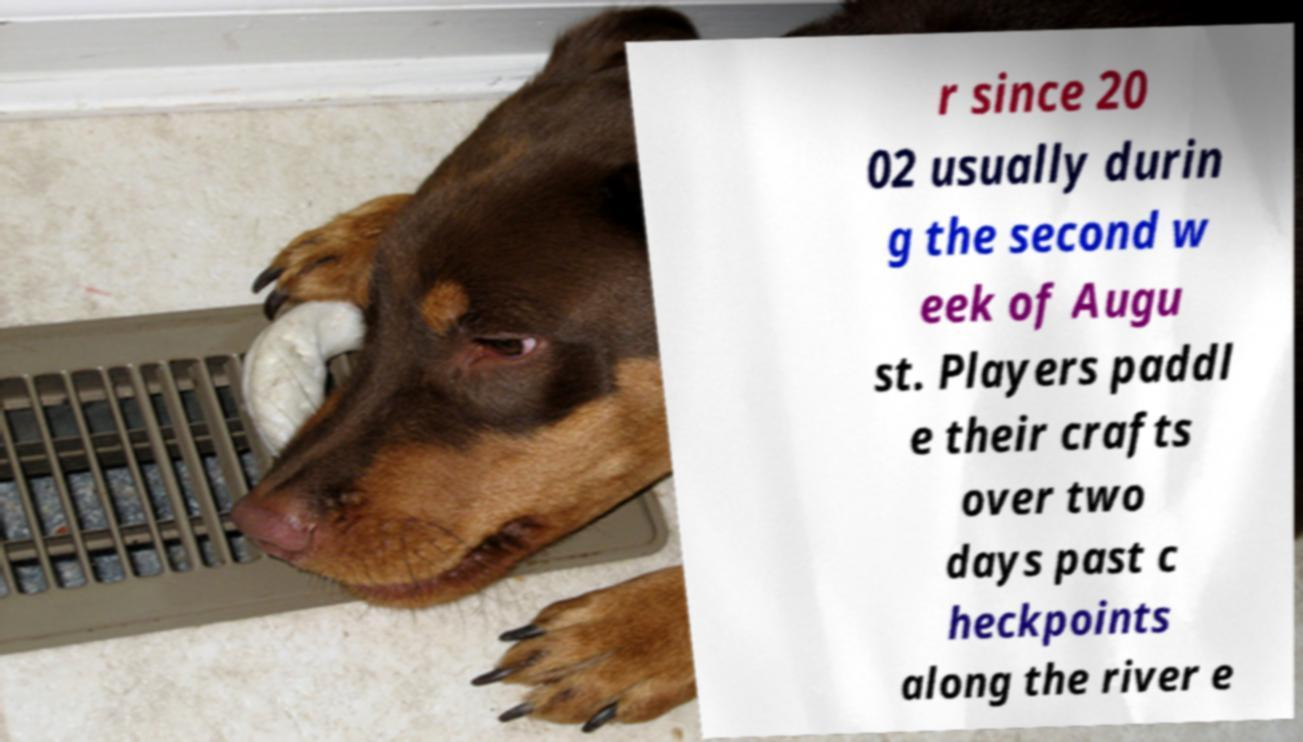For documentation purposes, I need the text within this image transcribed. Could you provide that? r since 20 02 usually durin g the second w eek of Augu st. Players paddl e their crafts over two days past c heckpoints along the river e 